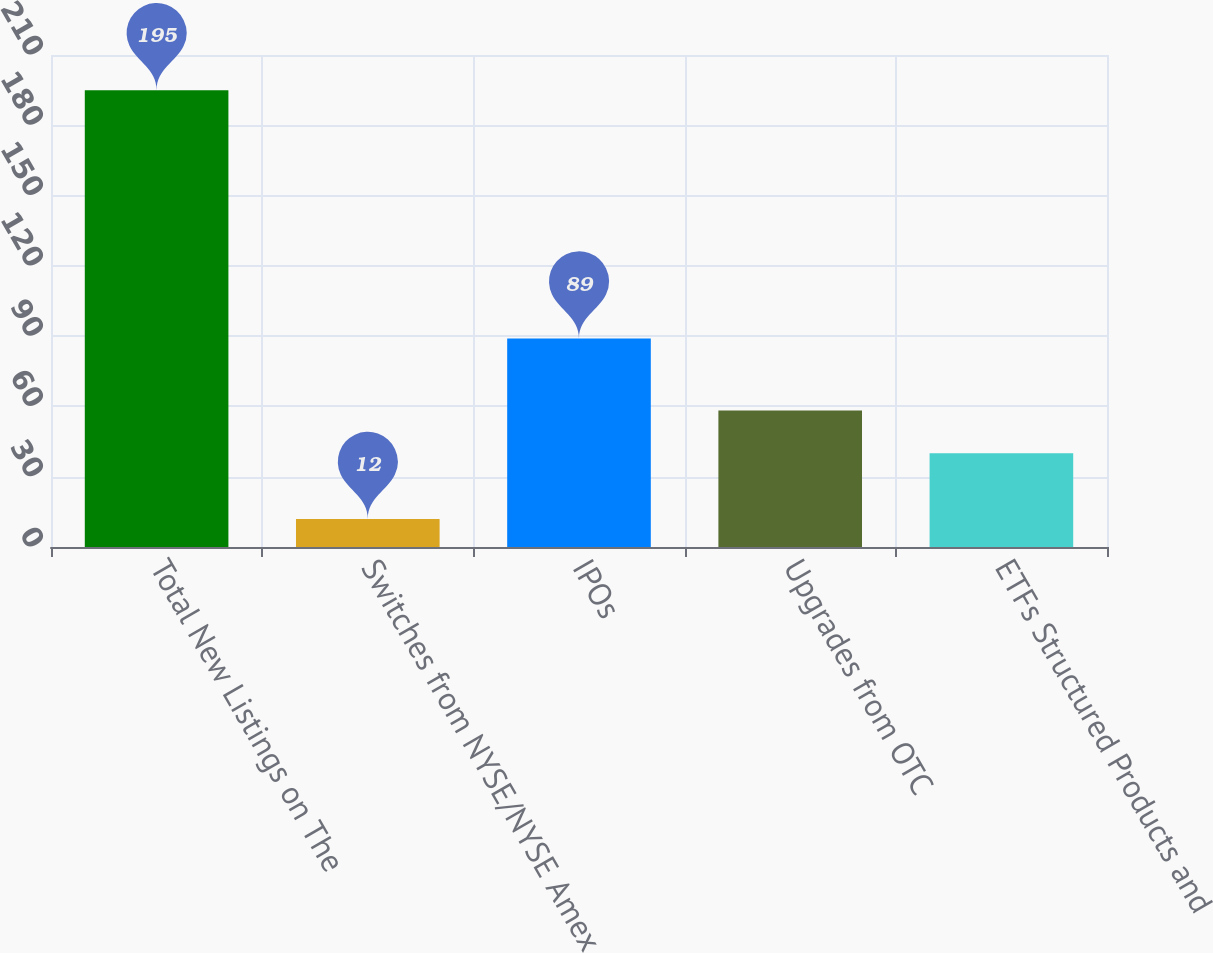Convert chart. <chart><loc_0><loc_0><loc_500><loc_500><bar_chart><fcel>Total New Listings on The<fcel>Switches from NYSE/NYSE Amex<fcel>IPOs<fcel>Upgrades from OTC<fcel>ETFs Structured Products and<nl><fcel>195<fcel>12<fcel>89<fcel>58.3<fcel>40<nl></chart> 